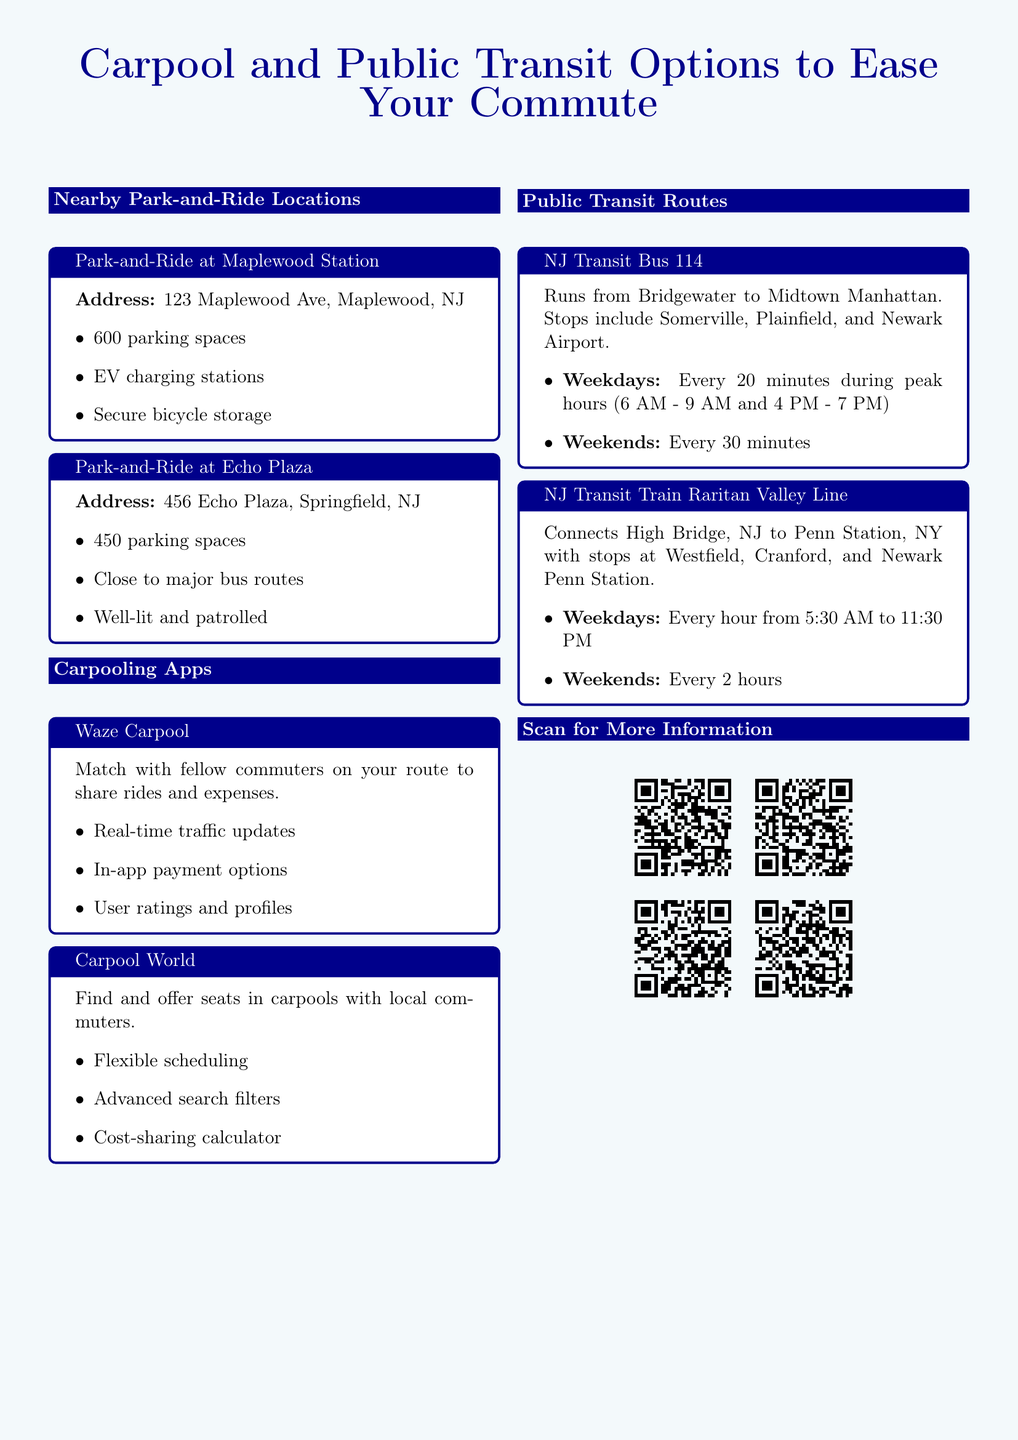What is the address of the Park-and-Ride at Maplewood Station? The address is explicitly stated in the document, which is 123 Maplewood Ave, Maplewood, NJ.
Answer: 123 Maplewood Ave, Maplewood, NJ How many parking spaces are available at Echo Plaza? The document lists the number of parking spaces for Echo Plaza, which is 450.
Answer: 450 What are the operating hours for the NJ Transit Train Raritan Valley Line on weekdays? The operating hours are found in the section describing the train schedule, which is from 5:30 AM to 11:30 PM.
Answer: 5:30 AM to 11:30 PM Which carpooling app offers real-time traffic updates? The document mentions Waze Carpool as providing real-time traffic updates.
Answer: Waze Carpool What is the frequency of the NJ Transit Bus 114 on weekends? The document specifies that the bus runs every 30 minutes on weekends.
Answer: Every 30 minutes What type of services does the Park-and-Ride at Maplewood Station offer? The services are detailed in the features list, including EV charging stations and secure bicycle storage.
Answer: EV charging stations, secure bicycle storage Which carpooling app includes a cost-sharing calculator? The document explicitly states that Carpool World has a cost-sharing calculator.
Answer: Carpool World What should you do to access more information about public transit routes? The document advises the reader to scan the QR codes for additional information.
Answer: Scan the QR codes 